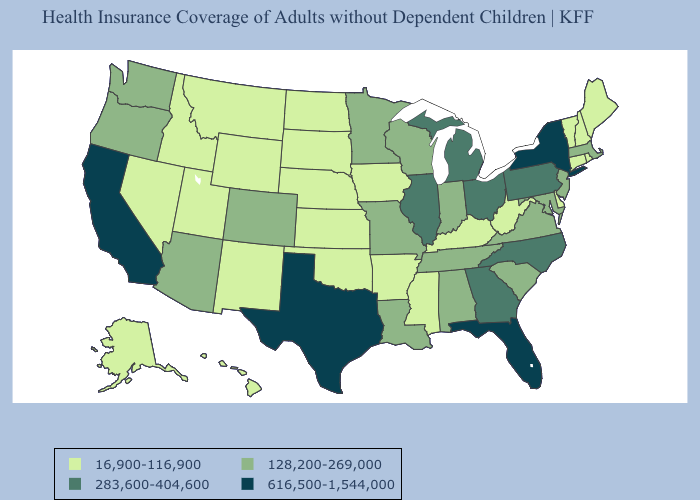Among the states that border Louisiana , does Mississippi have the highest value?
Short answer required. No. Does Michigan have the highest value in the MidWest?
Keep it brief. Yes. What is the highest value in states that border Alabama?
Answer briefly. 616,500-1,544,000. Among the states that border Tennessee , does Georgia have the lowest value?
Short answer required. No. Does Rhode Island have the same value as Kansas?
Concise answer only. Yes. What is the highest value in states that border Virginia?
Quick response, please. 283,600-404,600. Among the states that border Montana , which have the lowest value?
Answer briefly. Idaho, North Dakota, South Dakota, Wyoming. Name the states that have a value in the range 283,600-404,600?
Answer briefly. Georgia, Illinois, Michigan, North Carolina, Ohio, Pennsylvania. What is the lowest value in states that border Oregon?
Write a very short answer. 16,900-116,900. Which states have the lowest value in the USA?
Write a very short answer. Alaska, Arkansas, Connecticut, Delaware, Hawaii, Idaho, Iowa, Kansas, Kentucky, Maine, Mississippi, Montana, Nebraska, Nevada, New Hampshire, New Mexico, North Dakota, Oklahoma, Rhode Island, South Dakota, Utah, Vermont, West Virginia, Wyoming. Which states have the lowest value in the USA?
Write a very short answer. Alaska, Arkansas, Connecticut, Delaware, Hawaii, Idaho, Iowa, Kansas, Kentucky, Maine, Mississippi, Montana, Nebraska, Nevada, New Hampshire, New Mexico, North Dakota, Oklahoma, Rhode Island, South Dakota, Utah, Vermont, West Virginia, Wyoming. What is the value of Connecticut?
Keep it brief. 16,900-116,900. Does Vermont have the lowest value in the Northeast?
Give a very brief answer. Yes. What is the lowest value in the South?
Short answer required. 16,900-116,900. 